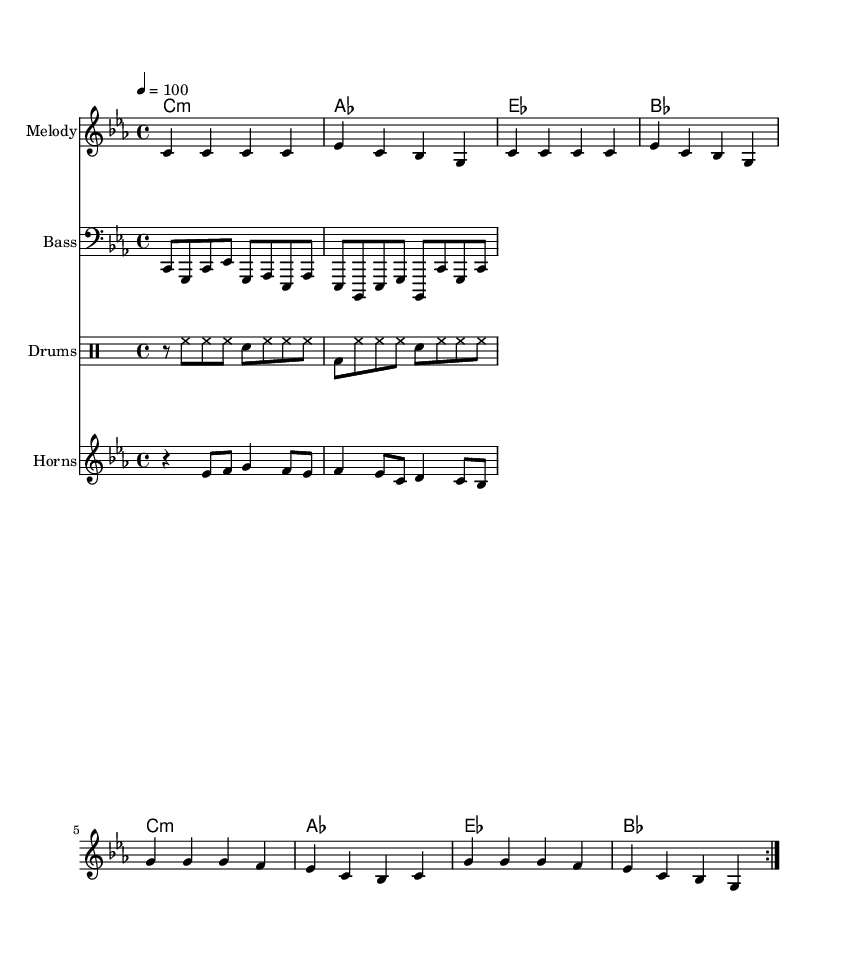What is the key signature of this music? The key signature indicates C minor, which has three flats (B flat, E flat, and A flat). This is derived from the key signature marked at the beginning of the score.
Answer: C minor What is the time signature used in this piece? The time signature shown in the score is 4/4, meaning there are four beats in each measure and the quarter note gets one beat. This is clearly indicated at the beginning of the score.
Answer: 4/4 What is the tempo marking for this piece? The tempo marking is shown as "4 = 100," meaning a quarter note receives a tempo of 100 beats per minute. This is situated above the staff in the score.
Answer: 100 How many measures are repeated in the melody? The melody includes a repeat section as indicated by "volta 2" which signifies the two repetitions of the given melodies within a specific range.
Answer: 2 What is the highest note in the melody? The highest note in the melody is G, which can be identified by looking at the notes in the melody line where G is the highest pitch reached throughout the measures.
Answer: G Which chord is most frequently used in the harmony? The harmonic progression shows that C minor is the most frequently used chord, as it is the starting chord of each line in the chord section.
Answer: C minor What type of percussion instruments are presented in this score? The score specifically incorporates a drum staff setup, which prominently features high hats and bass drums, as indicated by their notations in the drummode section.
Answer: Drums 